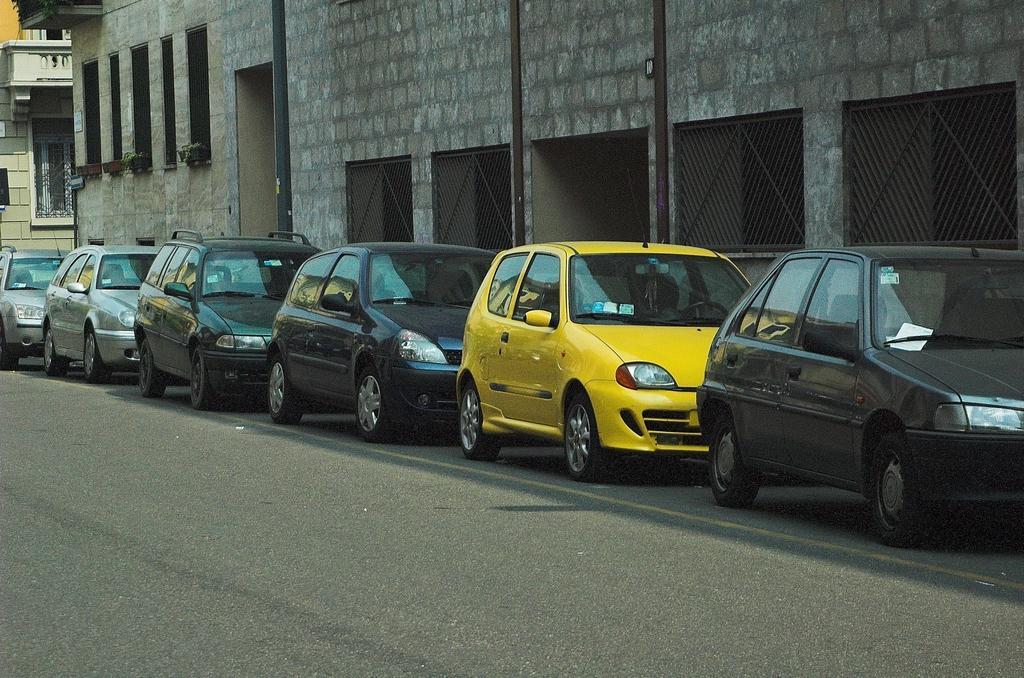Please provide a concise description of this image. There is a road. On the side of the road there are cars. Also there are buildings with brick wall. On the wall there are windows. Near to that that there are pot with plants. Also there are windows with mesh. 